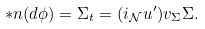<formula> <loc_0><loc_0><loc_500><loc_500>\ast n ( d \phi ) = \Sigma _ { t } = ( i _ { \mathcal { N } } u ^ { \prime } ) v _ { \Sigma } \Sigma .</formula> 